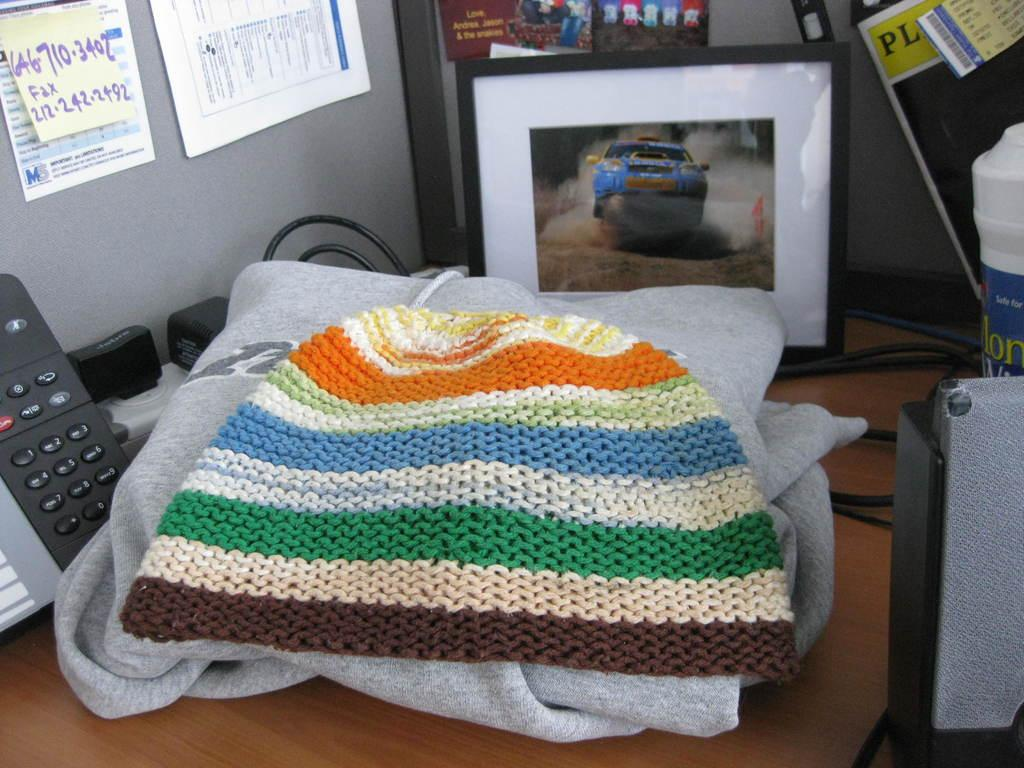What object in the image is typically used for communication? There is a telephone in the image, which is typically used for communication. What type of wire is visible in the image? There is a cable wire in the image. What is the frame in the image used for? The frame in the image is likely used for displaying or holding something, but the specific purpose is not mentioned in the facts. What type of items can be seen in the image that are typically used for writing or documentation? There are papers in the image that are typically used for writing or documentation. What type of personal items can be seen in the image? There are clothes and a cap in the image. What type of cake is being served on a spoon in the image? There is no cake or spoon present in the image. How does the feeling of the clothes in the image compare to the feeling of the cap? The facts provided do not give any information about the texture or feeling of the clothes or cap, so it is not possible to compare their feelings. 